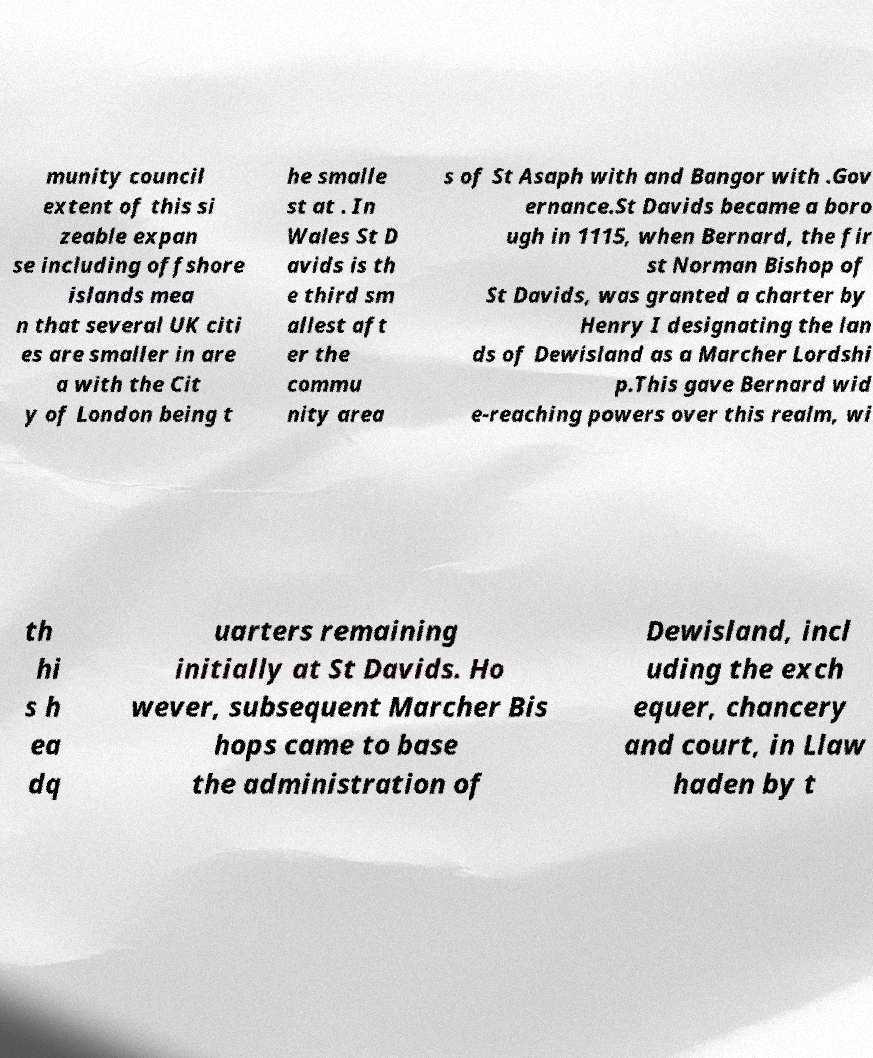There's text embedded in this image that I need extracted. Can you transcribe it verbatim? munity council extent of this si zeable expan se including offshore islands mea n that several UK citi es are smaller in are a with the Cit y of London being t he smalle st at . In Wales St D avids is th e third sm allest aft er the commu nity area s of St Asaph with and Bangor with .Gov ernance.St Davids became a boro ugh in 1115, when Bernard, the fir st Norman Bishop of St Davids, was granted a charter by Henry I designating the lan ds of Dewisland as a Marcher Lordshi p.This gave Bernard wid e-reaching powers over this realm, wi th hi s h ea dq uarters remaining initially at St Davids. Ho wever, subsequent Marcher Bis hops came to base the administration of Dewisland, incl uding the exch equer, chancery and court, in Llaw haden by t 